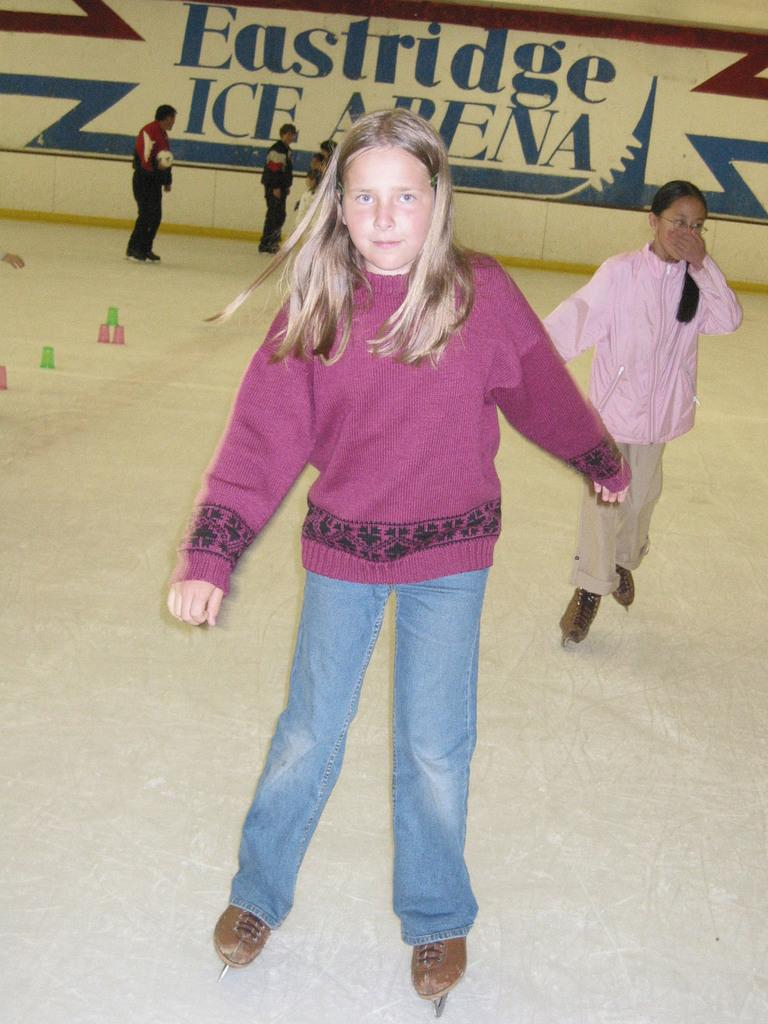What activity are the people in the image engaged in? The people in the image are doing skating. Can you describe the background of the image? There is a painting on the wall in the background of the image. How many deer are present in the image? There are no deer present in the image; it features people doing skating and a painting on the wall in the background. 